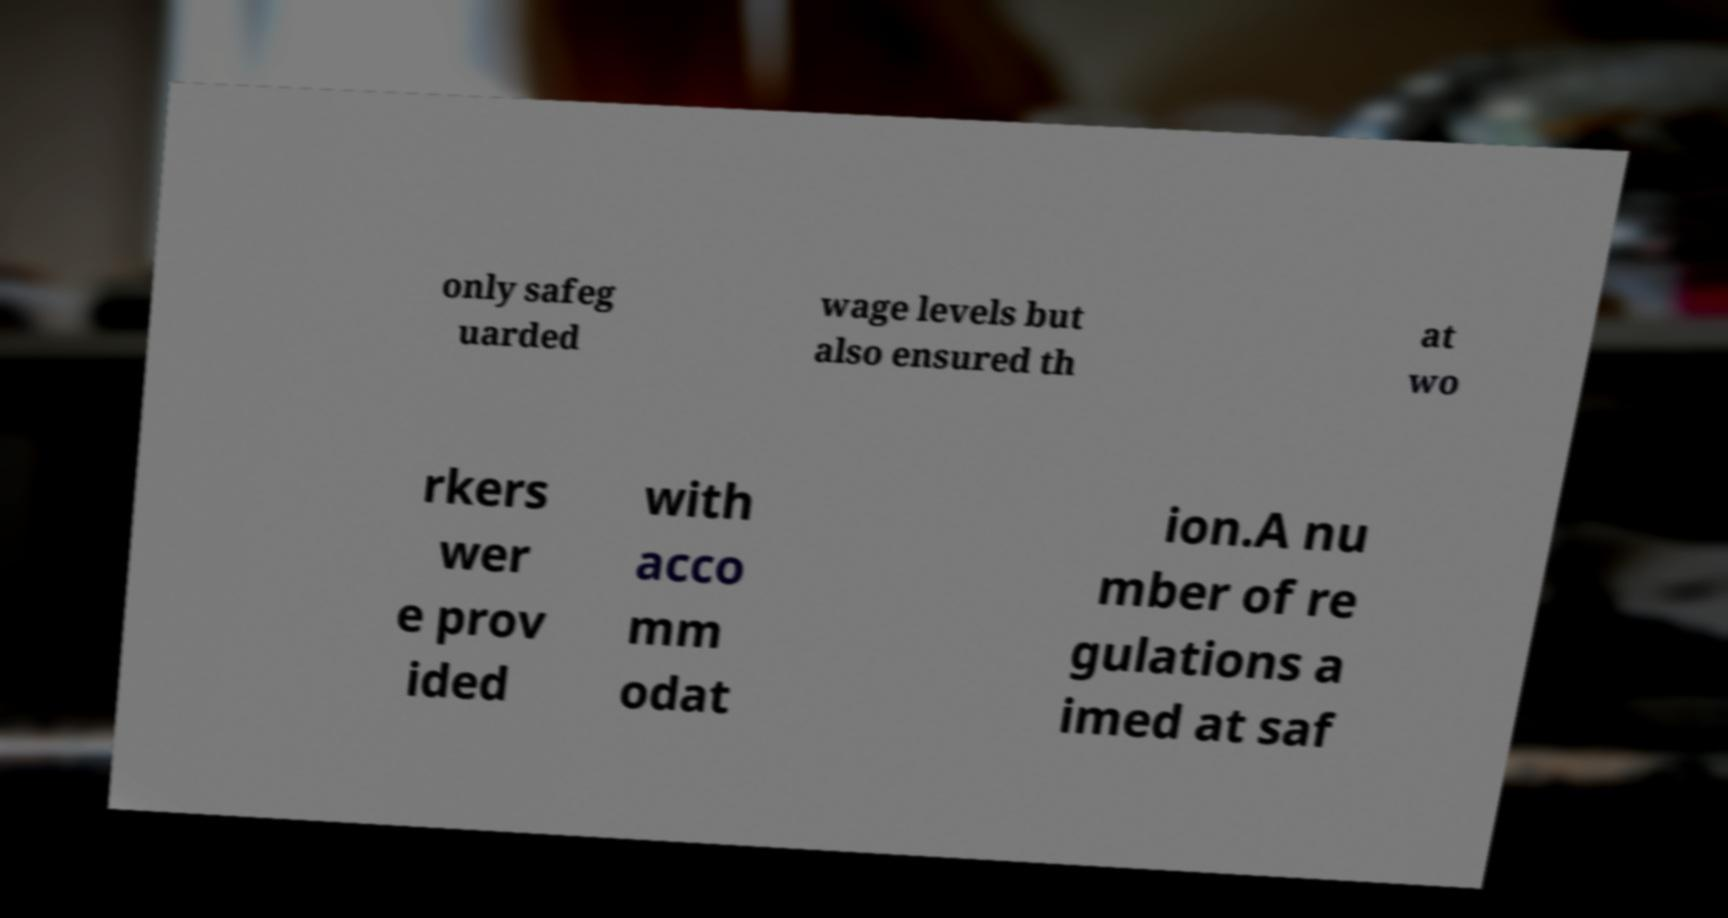Could you extract and type out the text from this image? only safeg uarded wage levels but also ensured th at wo rkers wer e prov ided with acco mm odat ion.A nu mber of re gulations a imed at saf 